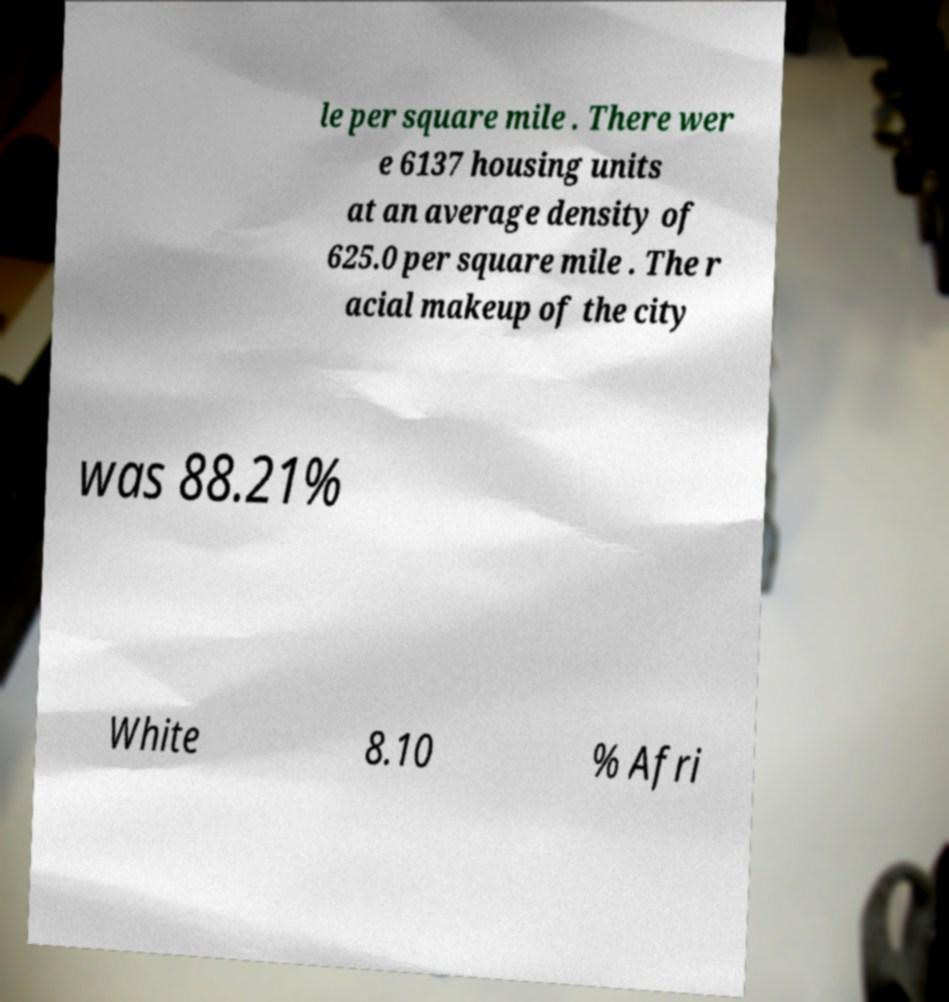Could you extract and type out the text from this image? le per square mile . There wer e 6137 housing units at an average density of 625.0 per square mile . The r acial makeup of the city was 88.21% White 8.10 % Afri 